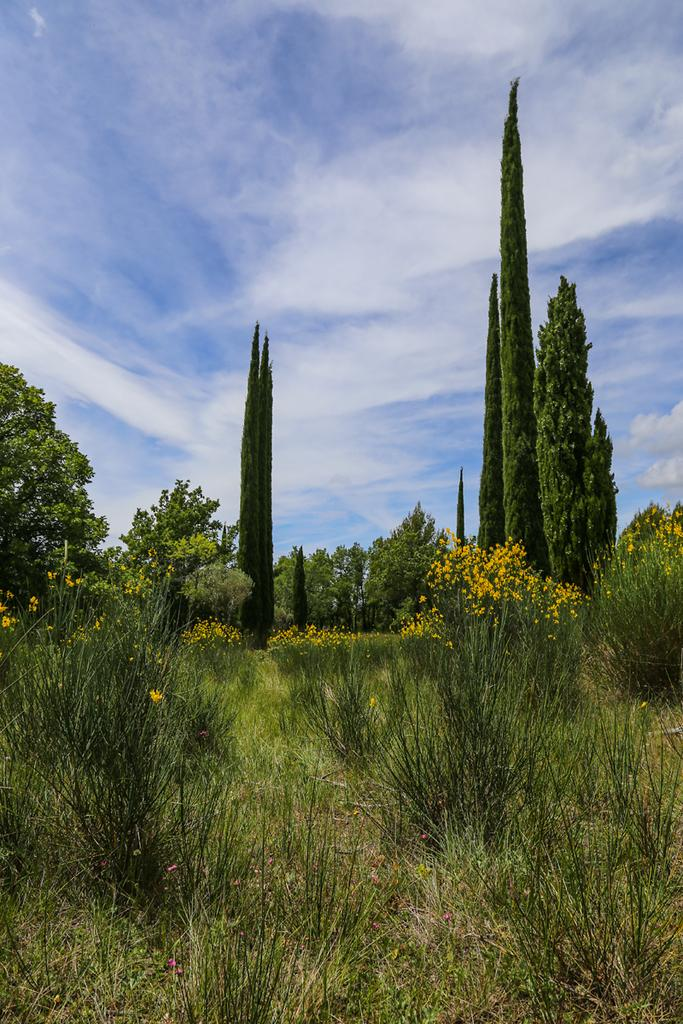What types of vegetation can be seen in the image? There are many plants and trees in the image. Are there any specific features of the plants in the image? Some of the plants have beautiful flowers. What is the tendency of the balloon to float away in the image? There is no balloon present in the image, so it is not possible to determine its tendency to float away. 